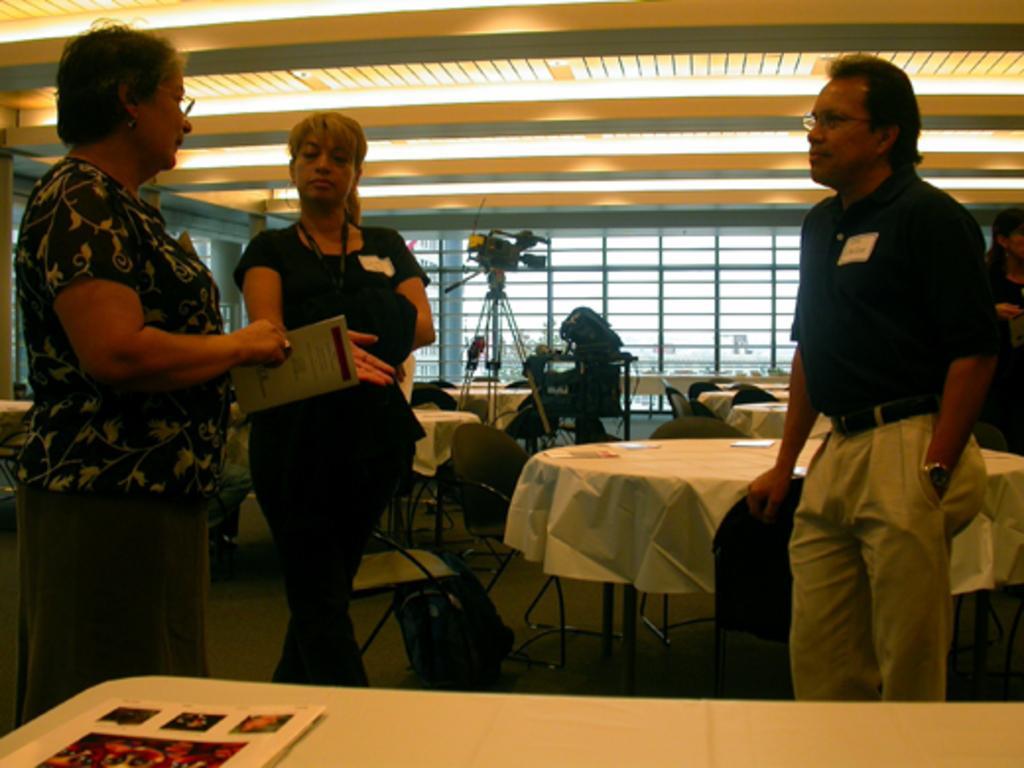Please provide a concise description of this image. In this image I can see two women and a man are standing. Here I can see two of them are wearing specs. In the background I can see few tables, few chairs and a camera. 